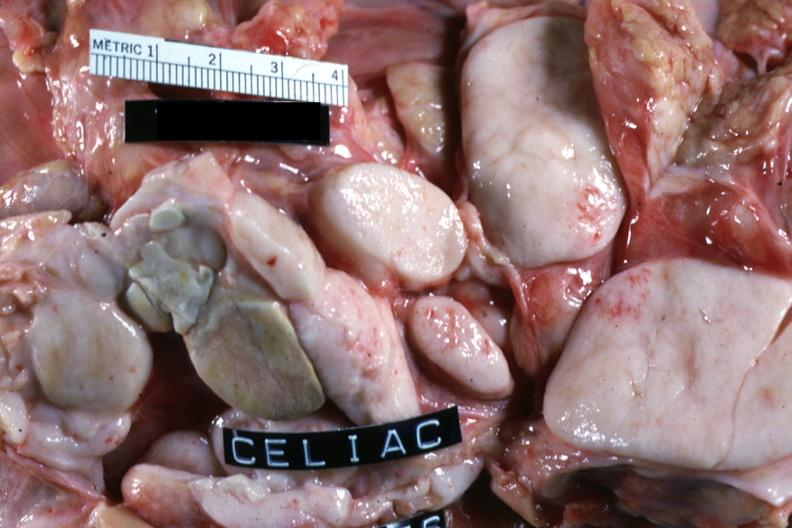what does this image show?
Answer the question using a single word or phrase. Close-up of large matted ivory white nodes good example cell type not described non-hodgkins 